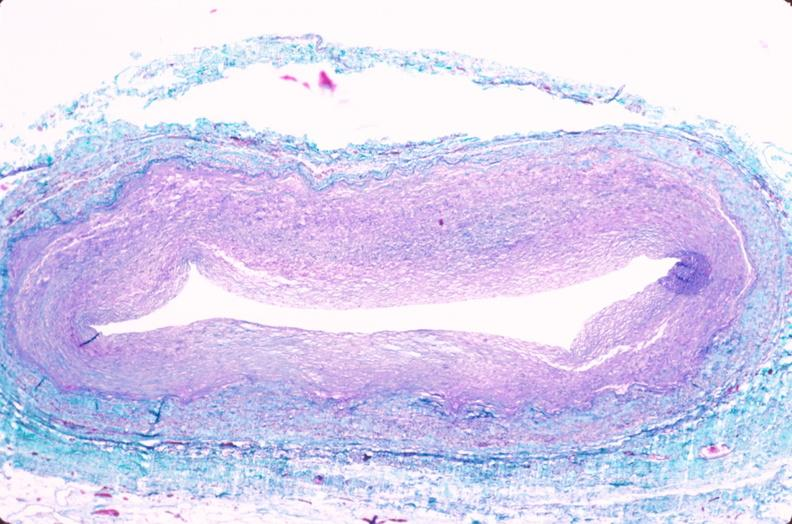does this image show saphenous vein graft sclerosis?
Answer the question using a single word or phrase. Yes 